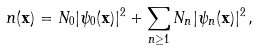<formula> <loc_0><loc_0><loc_500><loc_500>n ( \mathbf x ) = N _ { 0 } | \psi _ { 0 } ( \mathbf x ) | ^ { 2 } + \sum _ { n \geq 1 } N _ { n } | \psi _ { n } ( \mathbf x ) | ^ { 2 } \, ,</formula> 